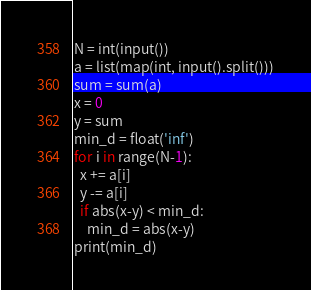Convert code to text. <code><loc_0><loc_0><loc_500><loc_500><_Python_>N = int(input())
a = list(map(int, input().split()))
sum = sum(a)
x = 0
y = sum
min_d = float('inf')
for i in range(N-1):
  x += a[i]
  y -= a[i]
  if abs(x-y) < min_d:
    min_d = abs(x-y)
print(min_d)
</code> 